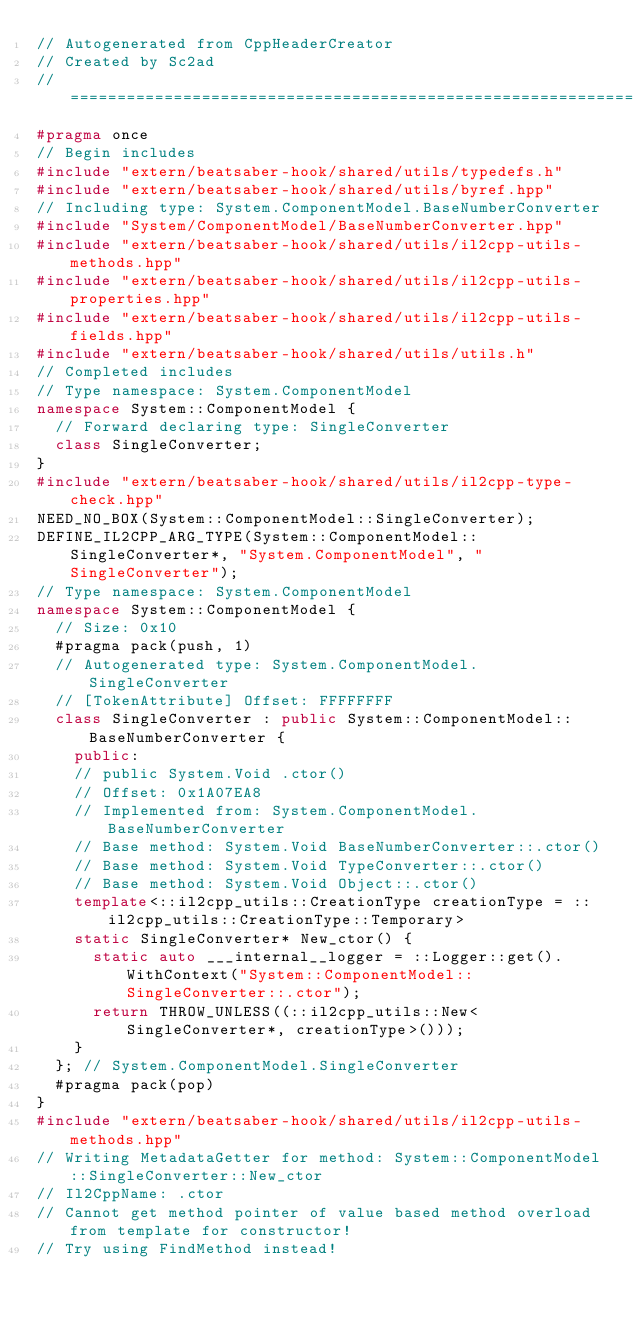Convert code to text. <code><loc_0><loc_0><loc_500><loc_500><_C++_>// Autogenerated from CppHeaderCreator
// Created by Sc2ad
// =========================================================================
#pragma once
// Begin includes
#include "extern/beatsaber-hook/shared/utils/typedefs.h"
#include "extern/beatsaber-hook/shared/utils/byref.hpp"
// Including type: System.ComponentModel.BaseNumberConverter
#include "System/ComponentModel/BaseNumberConverter.hpp"
#include "extern/beatsaber-hook/shared/utils/il2cpp-utils-methods.hpp"
#include "extern/beatsaber-hook/shared/utils/il2cpp-utils-properties.hpp"
#include "extern/beatsaber-hook/shared/utils/il2cpp-utils-fields.hpp"
#include "extern/beatsaber-hook/shared/utils/utils.h"
// Completed includes
// Type namespace: System.ComponentModel
namespace System::ComponentModel {
  // Forward declaring type: SingleConverter
  class SingleConverter;
}
#include "extern/beatsaber-hook/shared/utils/il2cpp-type-check.hpp"
NEED_NO_BOX(System::ComponentModel::SingleConverter);
DEFINE_IL2CPP_ARG_TYPE(System::ComponentModel::SingleConverter*, "System.ComponentModel", "SingleConverter");
// Type namespace: System.ComponentModel
namespace System::ComponentModel {
  // Size: 0x10
  #pragma pack(push, 1)
  // Autogenerated type: System.ComponentModel.SingleConverter
  // [TokenAttribute] Offset: FFFFFFFF
  class SingleConverter : public System::ComponentModel::BaseNumberConverter {
    public:
    // public System.Void .ctor()
    // Offset: 0x1A07EA8
    // Implemented from: System.ComponentModel.BaseNumberConverter
    // Base method: System.Void BaseNumberConverter::.ctor()
    // Base method: System.Void TypeConverter::.ctor()
    // Base method: System.Void Object::.ctor()
    template<::il2cpp_utils::CreationType creationType = ::il2cpp_utils::CreationType::Temporary>
    static SingleConverter* New_ctor() {
      static auto ___internal__logger = ::Logger::get().WithContext("System::ComponentModel::SingleConverter::.ctor");
      return THROW_UNLESS((::il2cpp_utils::New<SingleConverter*, creationType>()));
    }
  }; // System.ComponentModel.SingleConverter
  #pragma pack(pop)
}
#include "extern/beatsaber-hook/shared/utils/il2cpp-utils-methods.hpp"
// Writing MetadataGetter for method: System::ComponentModel::SingleConverter::New_ctor
// Il2CppName: .ctor
// Cannot get method pointer of value based method overload from template for constructor!
// Try using FindMethod instead!
</code> 